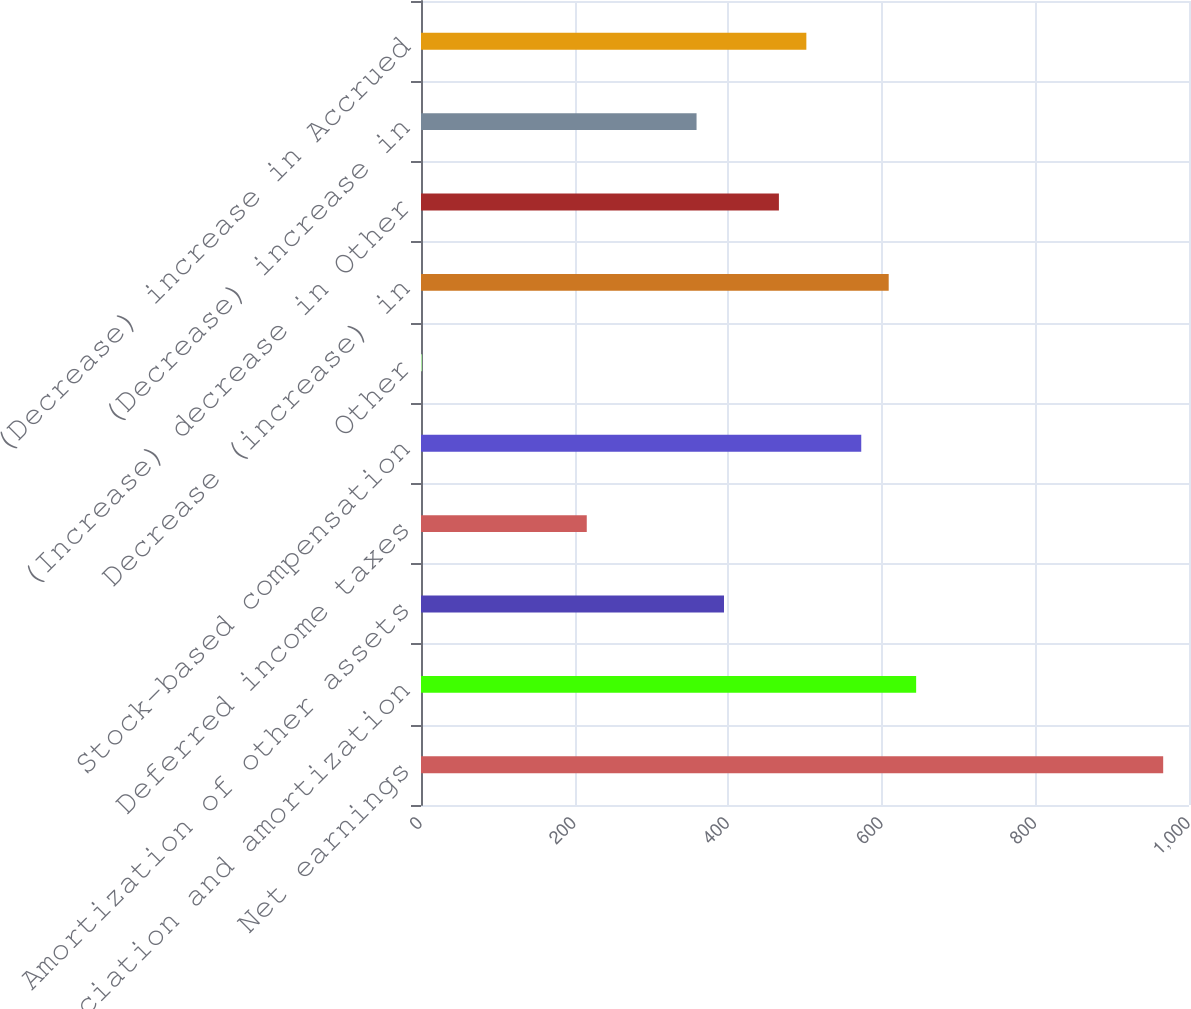Convert chart to OTSL. <chart><loc_0><loc_0><loc_500><loc_500><bar_chart><fcel>Net earnings<fcel>Depreciation and amortization<fcel>Amortization of other assets<fcel>Deferred income taxes<fcel>Stock-based compensation<fcel>Other<fcel>Decrease (increase) in<fcel>(Increase) decrease in Other<fcel>(Decrease) increase in<fcel>(Decrease) increase in Accrued<nl><fcel>966.38<fcel>644.72<fcel>394.54<fcel>215.84<fcel>573.24<fcel>1.4<fcel>608.98<fcel>466.02<fcel>358.8<fcel>501.76<nl></chart> 